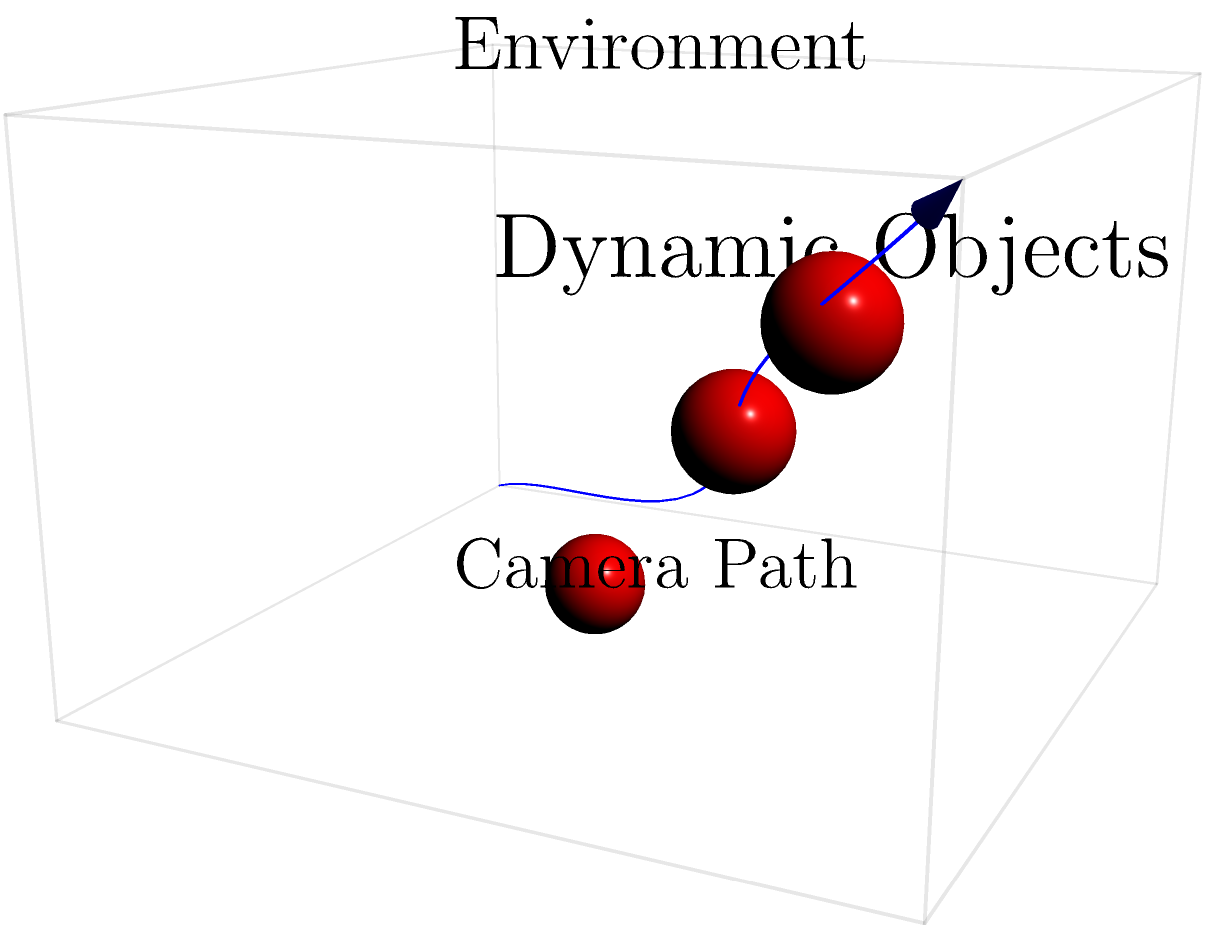In the context of estimating camera pose from a sequence of images in a dynamic environment, what technique would be most effective to handle the challenges posed by moving objects and maintain accurate 3D reconstruction? To estimate camera pose in a dynamic environment with moving objects, we need to consider several factors:

1. Feature extraction and matching:
   - Extract robust features (e.g., SIFT, SURF) from each image in the sequence.
   - Match features between consecutive frames.

2. Outlier rejection:
   - Use RANSAC (Random Sample Consensus) to filter out mismatches and features on moving objects.
   - This step is crucial for distinguishing between static and dynamic elements in the scene.

3. Motion segmentation:
   - Implement a motion segmentation algorithm (e.g., multi-view geometric constraints) to separate static and dynamic parts of the scene.
   - This helps in identifying which features belong to the static environment and which belong to moving objects.

4. Static structure estimation:
   - Use only the static features to estimate the camera pose and reconstruct the 3D structure of the environment.
   - This can be done using techniques like Structure from Motion (SfM) or Visual Simultaneous Localization and Mapping (VSLAM).

5. Dynamic object tracking:
   - Track the moving objects separately using methods like Kalman filtering or particle filtering.
   - This allows for maintaining a consistent model of the dynamic elements in the scene.

6. Bundle adjustment:
   - Perform global optimization of camera poses and 3D points using bundle adjustment.
   - This refines the estimated camera poses and 3D structure, improving overall accuracy.

7. Keyframe selection:
   - Select keyframes at regular intervals or based on significant camera motion.
   - This reduces redundancy and computational complexity while maintaining accuracy.

8. Loop closure detection:
   - Implement loop closure detection to recognize previously visited locations.
   - This helps in correcting accumulated drift and improving global consistency.

Given these considerations, the most effective technique to handle the challenges of a dynamic environment while maintaining accurate 3D reconstruction would be a robust Visual SLAM (Simultaneous Localization and Mapping) system with dynamic object handling capabilities.
Answer: Robust Visual SLAM with dynamic object handling 